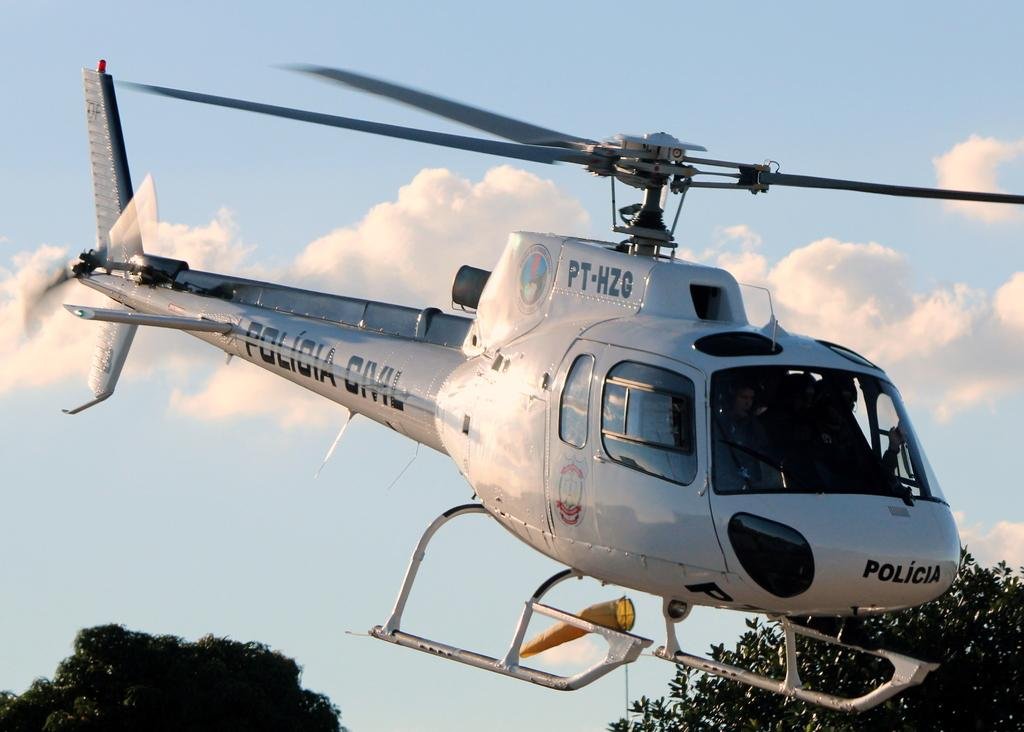What is the man in the image doing? The man is driving a helicopter in the image. What can be seen at the bottom of the image? There are trees visible at the bottom of the image. What is visible in the background of the image? The sky and clouds are visible in the background of the image. What type of copper material can be seen in the image? There is no copper material present in the image. Is there a scarecrow visible in the image? No, there is no scarecrow present in the image. 